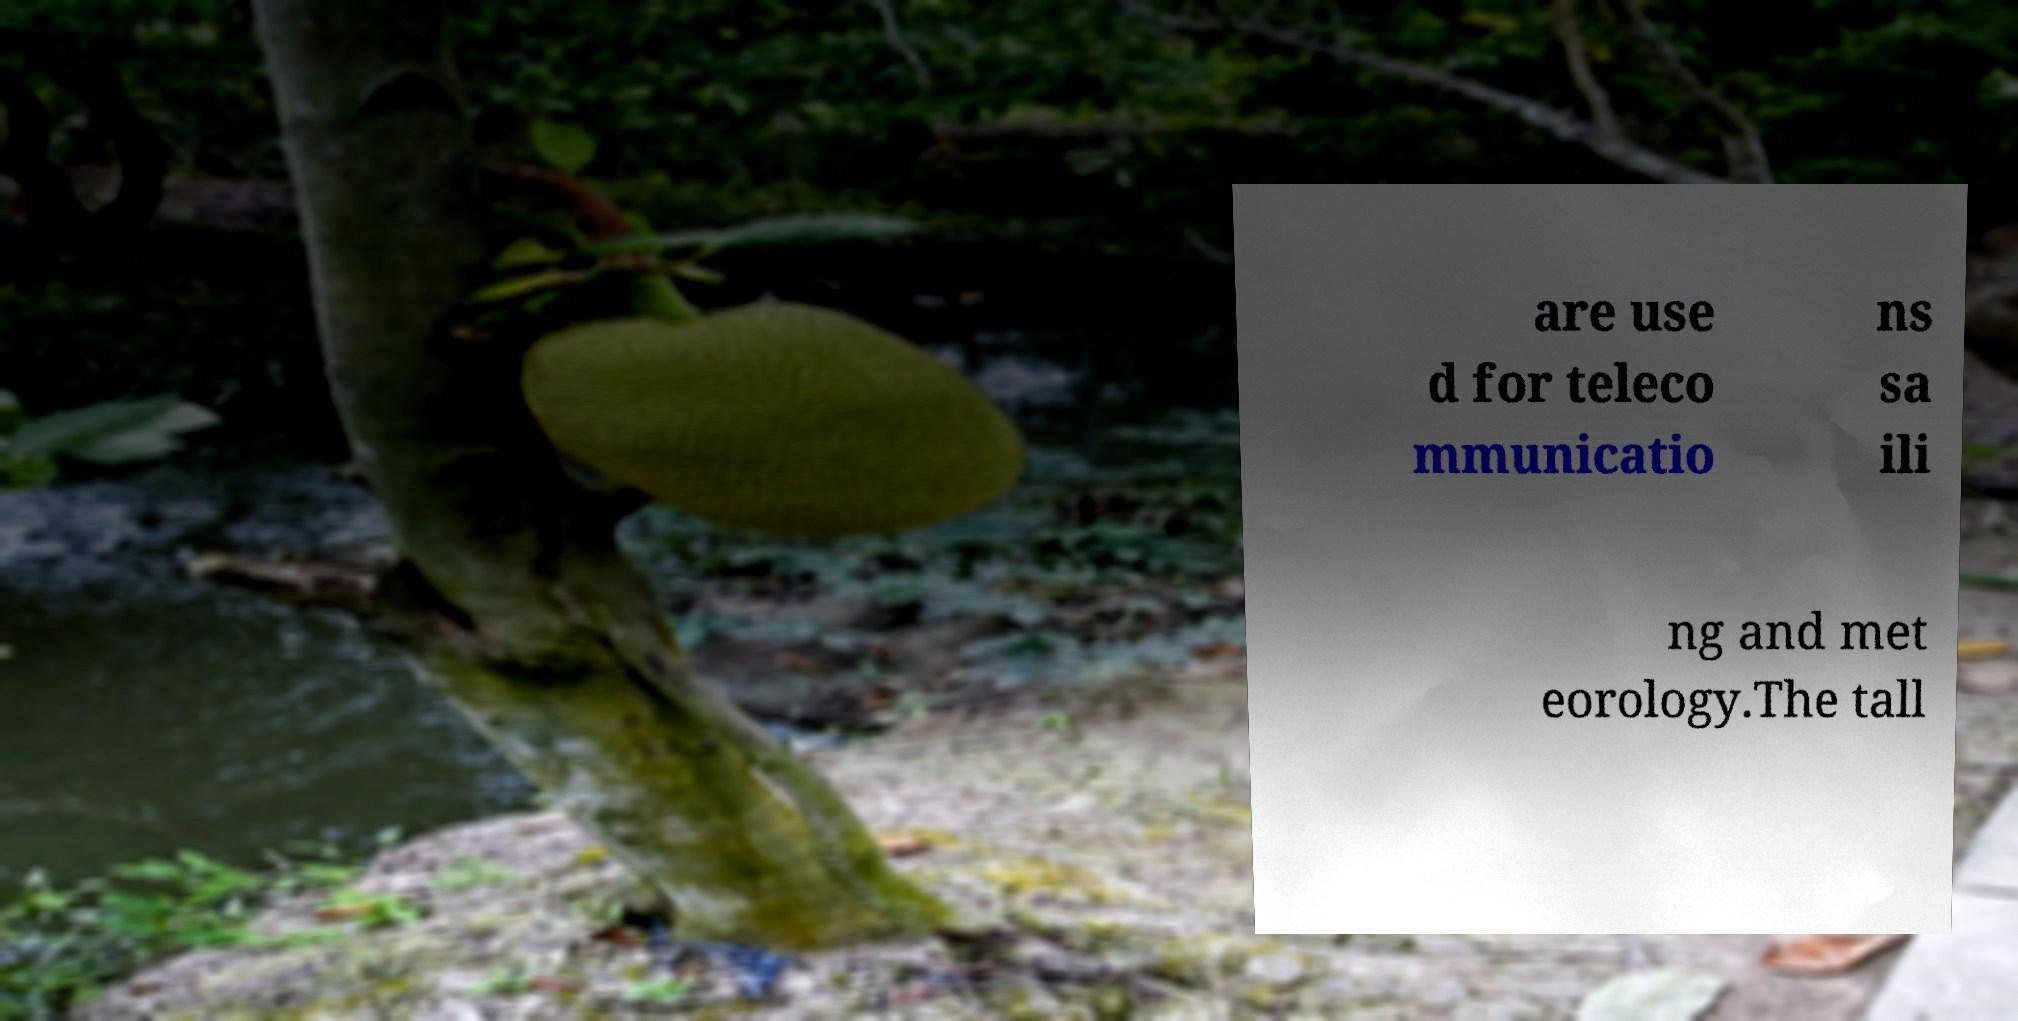Can you accurately transcribe the text from the provided image for me? are use d for teleco mmunicatio ns sa ili ng and met eorology.The tall 